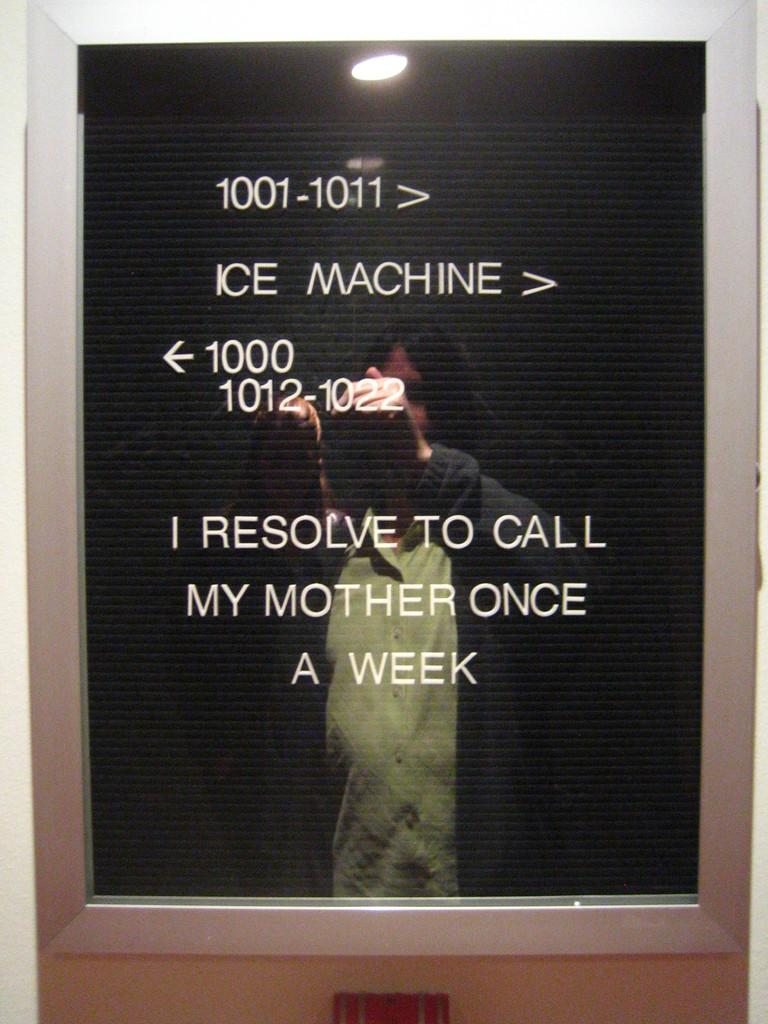<image>
Create a compact narrative representing the image presented. A person takes a picture of a board with directions to the ice machine. 